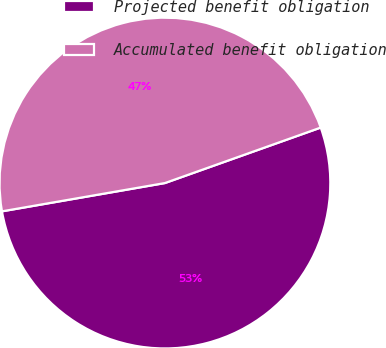Convert chart to OTSL. <chart><loc_0><loc_0><loc_500><loc_500><pie_chart><fcel>Projected benefit obligation<fcel>Accumulated benefit obligation<nl><fcel>52.71%<fcel>47.29%<nl></chart> 